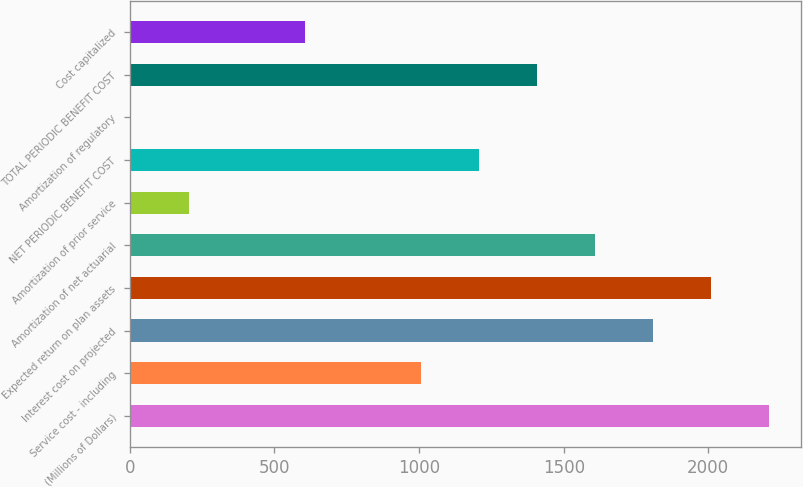Convert chart to OTSL. <chart><loc_0><loc_0><loc_500><loc_500><bar_chart><fcel>(Millions of Dollars)<fcel>Service cost - including<fcel>Interest cost on projected<fcel>Expected return on plan assets<fcel>Amortization of net actuarial<fcel>Amortization of prior service<fcel>NET PERIODIC BENEFIT COST<fcel>Amortization of regulatory<fcel>TOTAL PERIODIC BENEFIT COST<fcel>Cost capitalized<nl><fcel>2209.6<fcel>1006<fcel>1808.4<fcel>2009<fcel>1607.8<fcel>203.6<fcel>1206.6<fcel>3<fcel>1407.2<fcel>604.8<nl></chart> 